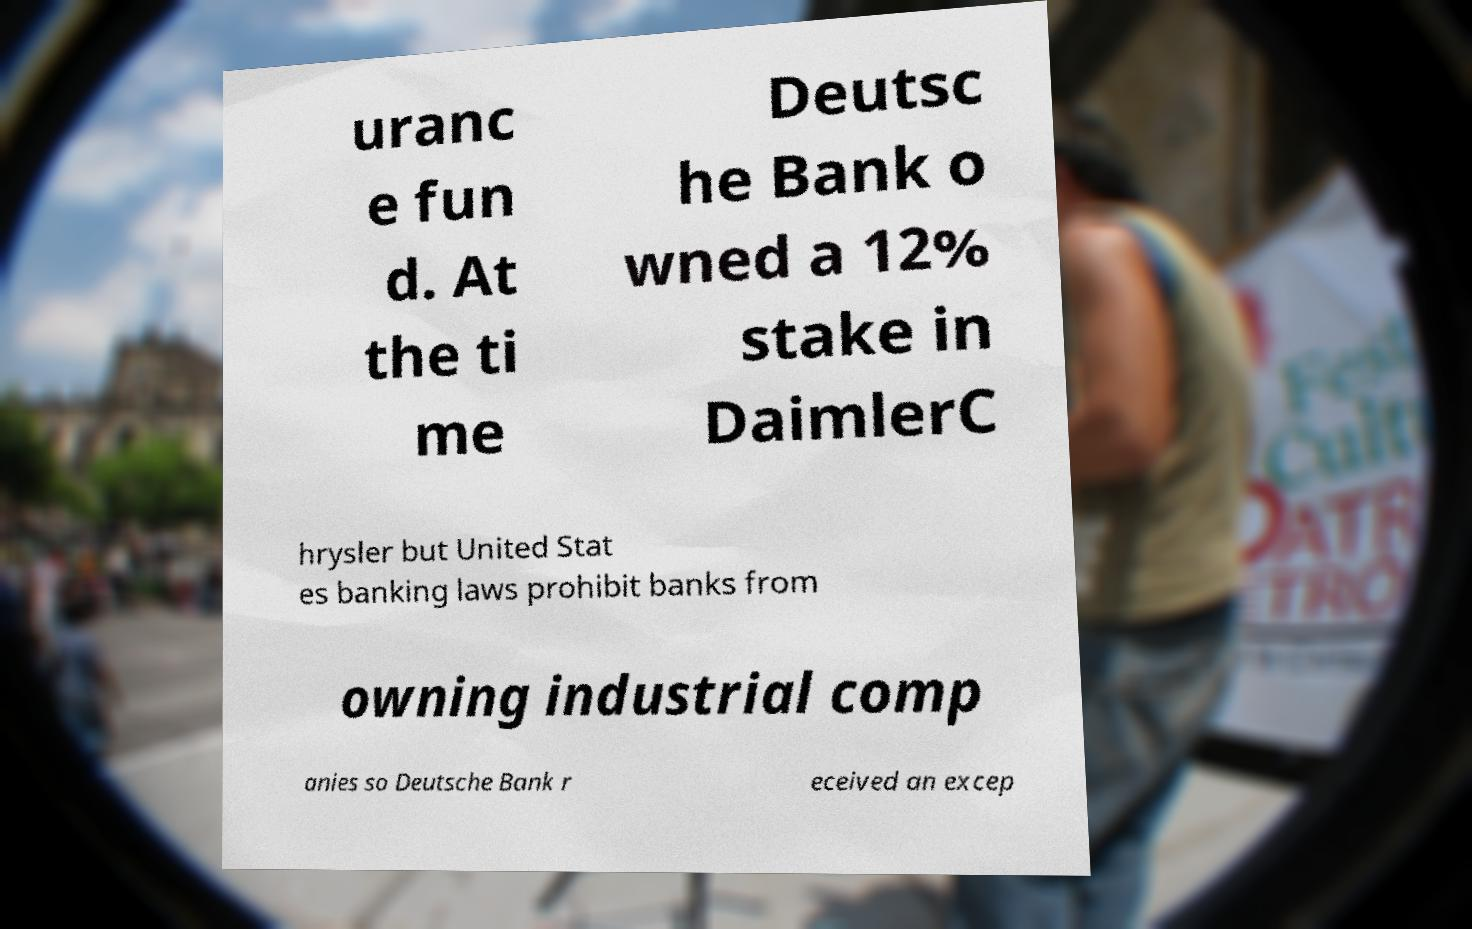Could you extract and type out the text from this image? uranc e fun d. At the ti me Deutsc he Bank o wned a 12% stake in DaimlerC hrysler but United Stat es banking laws prohibit banks from owning industrial comp anies so Deutsche Bank r eceived an excep 